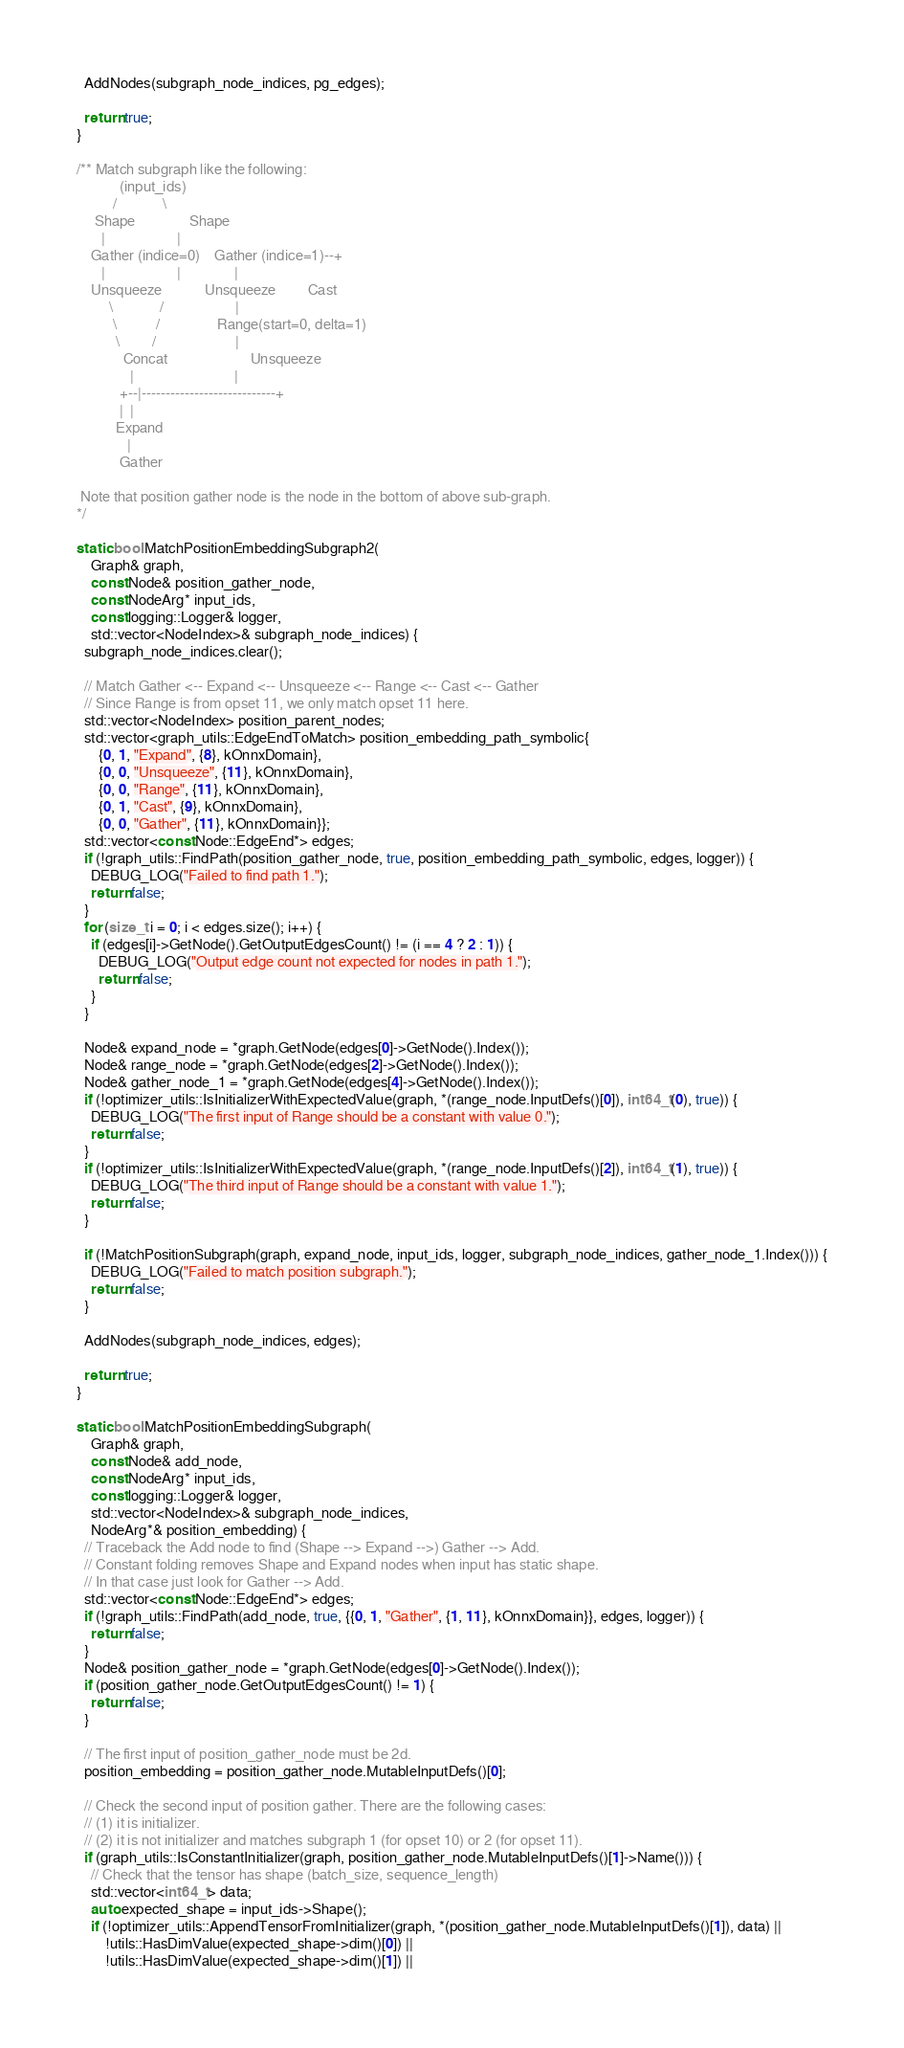Convert code to text. <code><loc_0><loc_0><loc_500><loc_500><_C++_>
  AddNodes(subgraph_node_indices, pg_edges);

  return true;
}

/** Match subgraph like the following:
            (input_ids)
          /             \
     Shape               Shape
       |                    |
    Gather (indice=0)    Gather (indice=1)--+
       |                    |               |
    Unsqueeze            Unsqueeze         Cast
         \             /                    |
          \           /                Range(start=0, delta=1)
           \         /                      |
             Concat                       Unsqueeze
               |                            |
            +--|----------------------------+
            |  |
           Expand
              |
            Gather

 Note that position gather node is the node in the bottom of above sub-graph.
*/

static bool MatchPositionEmbeddingSubgraph2(
    Graph& graph,
    const Node& position_gather_node,
    const NodeArg* input_ids,
    const logging::Logger& logger,
    std::vector<NodeIndex>& subgraph_node_indices) {
  subgraph_node_indices.clear();

  // Match Gather <-- Expand <-- Unsqueeze <-- Range <-- Cast <-- Gather
  // Since Range is from opset 11, we only match opset 11 here.
  std::vector<NodeIndex> position_parent_nodes;
  std::vector<graph_utils::EdgeEndToMatch> position_embedding_path_symbolic{
      {0, 1, "Expand", {8}, kOnnxDomain},
      {0, 0, "Unsqueeze", {11}, kOnnxDomain},
      {0, 0, "Range", {11}, kOnnxDomain},
      {0, 1, "Cast", {9}, kOnnxDomain},
      {0, 0, "Gather", {11}, kOnnxDomain}};
  std::vector<const Node::EdgeEnd*> edges;
  if (!graph_utils::FindPath(position_gather_node, true, position_embedding_path_symbolic, edges, logger)) {
    DEBUG_LOG("Failed to find path 1.");
    return false;
  }
  for (size_t i = 0; i < edges.size(); i++) {
    if (edges[i]->GetNode().GetOutputEdgesCount() != (i == 4 ? 2 : 1)) {
      DEBUG_LOG("Output edge count not expected for nodes in path 1.");
      return false;
    }
  }

  Node& expand_node = *graph.GetNode(edges[0]->GetNode().Index());
  Node& range_node = *graph.GetNode(edges[2]->GetNode().Index());
  Node& gather_node_1 = *graph.GetNode(edges[4]->GetNode().Index());
  if (!optimizer_utils::IsInitializerWithExpectedValue(graph, *(range_node.InputDefs()[0]), int64_t(0), true)) {
    DEBUG_LOG("The first input of Range should be a constant with value 0.");
    return false;
  }
  if (!optimizer_utils::IsInitializerWithExpectedValue(graph, *(range_node.InputDefs()[2]), int64_t(1), true)) {
    DEBUG_LOG("The third input of Range should be a constant with value 1.");
    return false;
  }

  if (!MatchPositionSubgraph(graph, expand_node, input_ids, logger, subgraph_node_indices, gather_node_1.Index())) {
    DEBUG_LOG("Failed to match position subgraph.");
    return false;
  }

  AddNodes(subgraph_node_indices, edges);

  return true;
}

static bool MatchPositionEmbeddingSubgraph(
    Graph& graph,
    const Node& add_node,
    const NodeArg* input_ids,
    const logging::Logger& logger,
    std::vector<NodeIndex>& subgraph_node_indices,
    NodeArg*& position_embedding) {
  // Traceback the Add node to find (Shape --> Expand -->) Gather --> Add.
  // Constant folding removes Shape and Expand nodes when input has static shape.
  // In that case just look for Gather --> Add.
  std::vector<const Node::EdgeEnd*> edges;
  if (!graph_utils::FindPath(add_node, true, {{0, 1, "Gather", {1, 11}, kOnnxDomain}}, edges, logger)) {
    return false;
  }
  Node& position_gather_node = *graph.GetNode(edges[0]->GetNode().Index());
  if (position_gather_node.GetOutputEdgesCount() != 1) {
    return false;
  }

  // The first input of position_gather_node must be 2d.
  position_embedding = position_gather_node.MutableInputDefs()[0];

  // Check the second input of position gather. There are the following cases:
  // (1) it is initializer.
  // (2) it is not initializer and matches subgraph 1 (for opset 10) or 2 (for opset 11).
  if (graph_utils::IsConstantInitializer(graph, position_gather_node.MutableInputDefs()[1]->Name())) {
    // Check that the tensor has shape (batch_size, sequence_length)
    std::vector<int64_t> data;
    auto expected_shape = input_ids->Shape();
    if (!optimizer_utils::AppendTensorFromInitializer(graph, *(position_gather_node.MutableInputDefs()[1]), data) ||
        !utils::HasDimValue(expected_shape->dim()[0]) ||
        !utils::HasDimValue(expected_shape->dim()[1]) ||</code> 